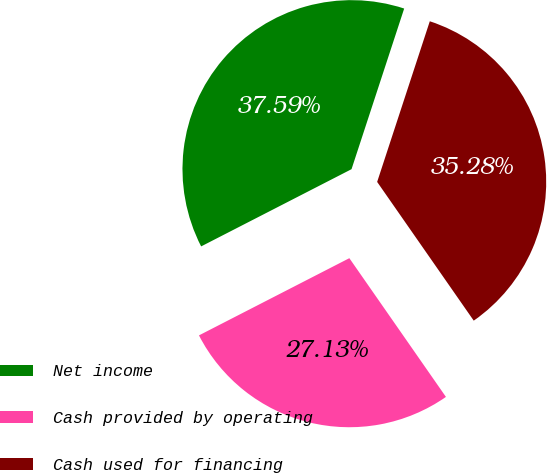Convert chart. <chart><loc_0><loc_0><loc_500><loc_500><pie_chart><fcel>Net income<fcel>Cash provided by operating<fcel>Cash used for financing<nl><fcel>37.59%<fcel>27.13%<fcel>35.28%<nl></chart> 